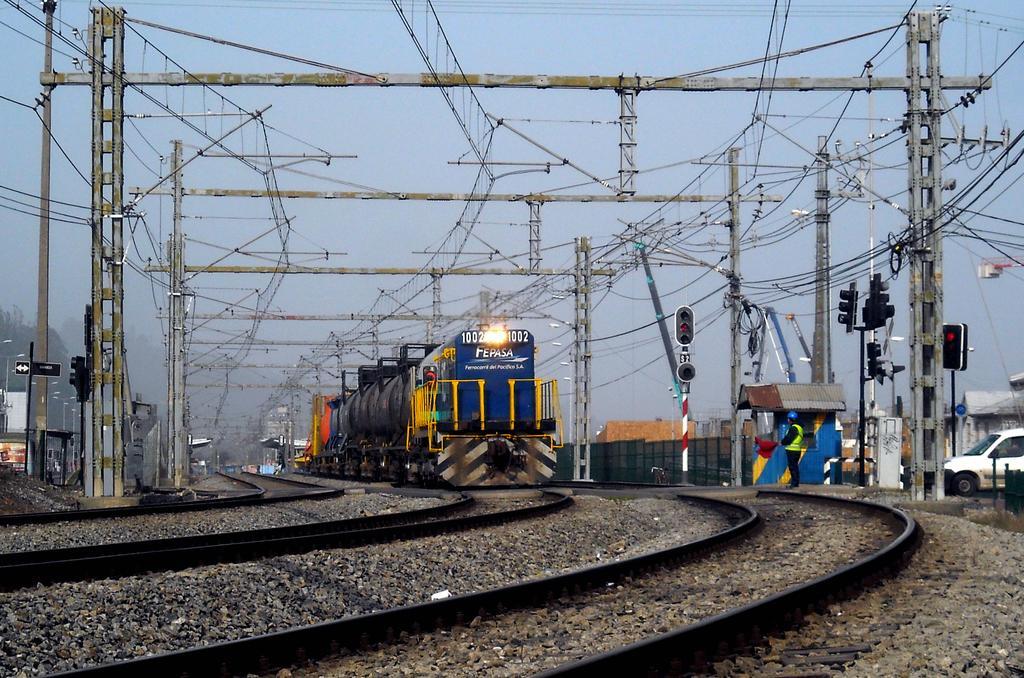In one or two sentences, can you explain what this image depicts? In this image I can see few railway tracks on the ground, few metal poles, few wires, a train which is blue, black, yellow and orange in color on the track, a white colored car, a person standing, few traffic signals and in the background I can see few trees, few buildings and the sky. 